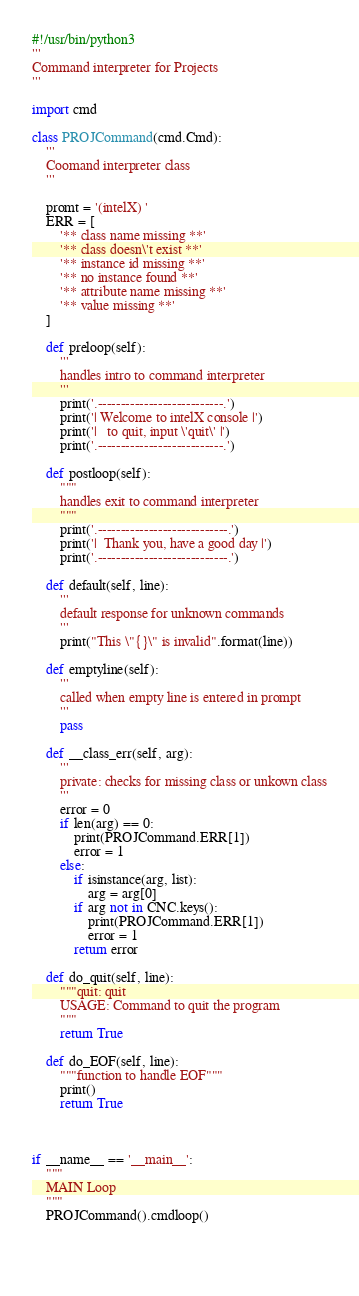<code> <loc_0><loc_0><loc_500><loc_500><_Python_>#!/usr/bin/python3
'''
Command interpreter for Projects 
'''

import cmd

class PROJCommand(cmd.Cmd):
    '''
    Coomand interpreter class
    '''

    promt = '(intelX) '
    ERR = [
        '** class name missing **'
        '** class doesn\'t exist **'
        '** instance id missing **'
        '** no instance found **'
        '** attribute name missing **'
        '** value missing **'
    ]

    def preloop(self):
        '''
        handles intro to command interpreter
        '''
        print('.---------------------------.')
        print('| Welcome to intelX console |')
        print('|   to quit, input \'quit\' |')
        print('.---------------------------.')

    def postloop(self):
        """
        handles exit to command interpreter
        """
        print('.----------------------------.')
        print('|  Thank you, have a good day |')
        print('.----------------------------.')

    def default(self, line):
        '''
        default response for unknown commands
        '''
        print("This \"{}\" is invalid".format(line))

    def emptyline(self):
        '''
        called when empty line is entered in prompt
        '''
        pass

    def __class_err(self, arg):
        '''
        private: checks for missing class or unkown class
        '''
        error = 0
        if len(arg) == 0:
            print(PROJCommand.ERR[1])
            error = 1
        else:
            if isinstance(arg, list):
                arg = arg[0]
            if arg not in CNC.keys():
                print(PROJCommand.ERR[1])
                error = 1
            return error

    def do_quit(self, line):
        """quit: quit
        USAGE: Command to quit the program
        """
        return True

    def do_EOF(self, line):
        """function to handle EOF"""
        print()
        return True

    

if __name__ == '__main__':
    """
    MAIN Loop
    """
    PROJCommand().cmdloop()
    

    
</code> 